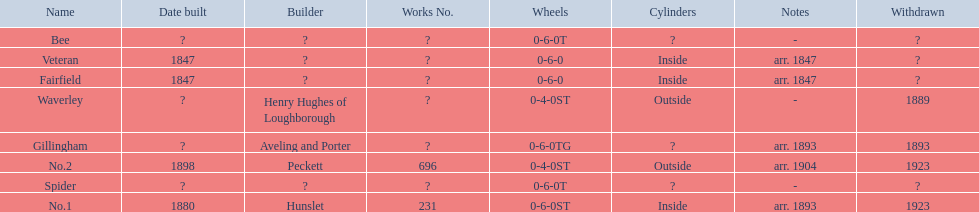What are the alderney railway names? Veteran, Fairfield, Waverley, Bee, Spider, Gillingham, No.1, No.2. When was the farfield built? 1847. What else was built that year? Veteran. Could you help me parse every detail presented in this table? {'header': ['Name', 'Date built', 'Builder', 'Works No.', 'Wheels', 'Cylinders', 'Notes', 'Withdrawn'], 'rows': [['Bee', '?', '?', '?', '0-6-0T', '?', '-', '?'], ['Veteran', '1847', '?', '?', '0-6-0', 'Inside', 'arr. 1847', '?'], ['Fairfield', '1847', '?', '?', '0-6-0', 'Inside', 'arr. 1847', '?'], ['Waverley', '?', 'Henry Hughes of Loughborough', '?', '0-4-0ST', 'Outside', '-', '1889'], ['Gillingham', '?', 'Aveling and Porter', '?', '0-6-0TG', '?', 'arr. 1893', '1893'], ['No.2', '1898', 'Peckett', '696', '0-4-0ST', 'Outside', 'arr. 1904', '1923'], ['Spider', '?', '?', '?', '0-6-0T', '?', '-', '?'], ['No.1', '1880', 'Hunslet', '231', '0-6-0ST', 'Inside', 'arr. 1893', '1923']]} 